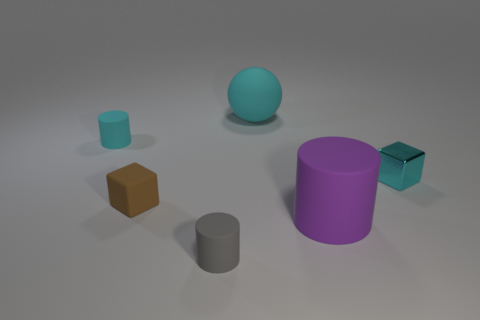Is there any other thing that is the same material as the cyan cube?
Your answer should be very brief. No. There is a rubber sphere that is the same color as the small metal block; what size is it?
Offer a terse response. Large. Do the cyan rubber object to the left of the small gray matte cylinder and the purple matte thing have the same shape?
Your answer should be very brief. Yes. Is the number of objects to the left of the sphere greater than the number of purple matte cylinders on the right side of the small cyan metallic object?
Your answer should be very brief. Yes. What number of rubber cylinders are to the left of the tiny matte thing that is in front of the purple matte cylinder?
Offer a very short reply. 1. There is another big object that is the same color as the shiny thing; what is its material?
Your answer should be compact. Rubber. How many other things are there of the same color as the tiny metallic block?
Offer a terse response. 2. There is a big thing that is in front of the cube to the right of the cyan matte sphere; what color is it?
Offer a very short reply. Purple. Are there any large matte cylinders of the same color as the tiny matte cube?
Offer a terse response. No. How many shiny objects are cyan cylinders or small yellow balls?
Offer a very short reply. 0. 